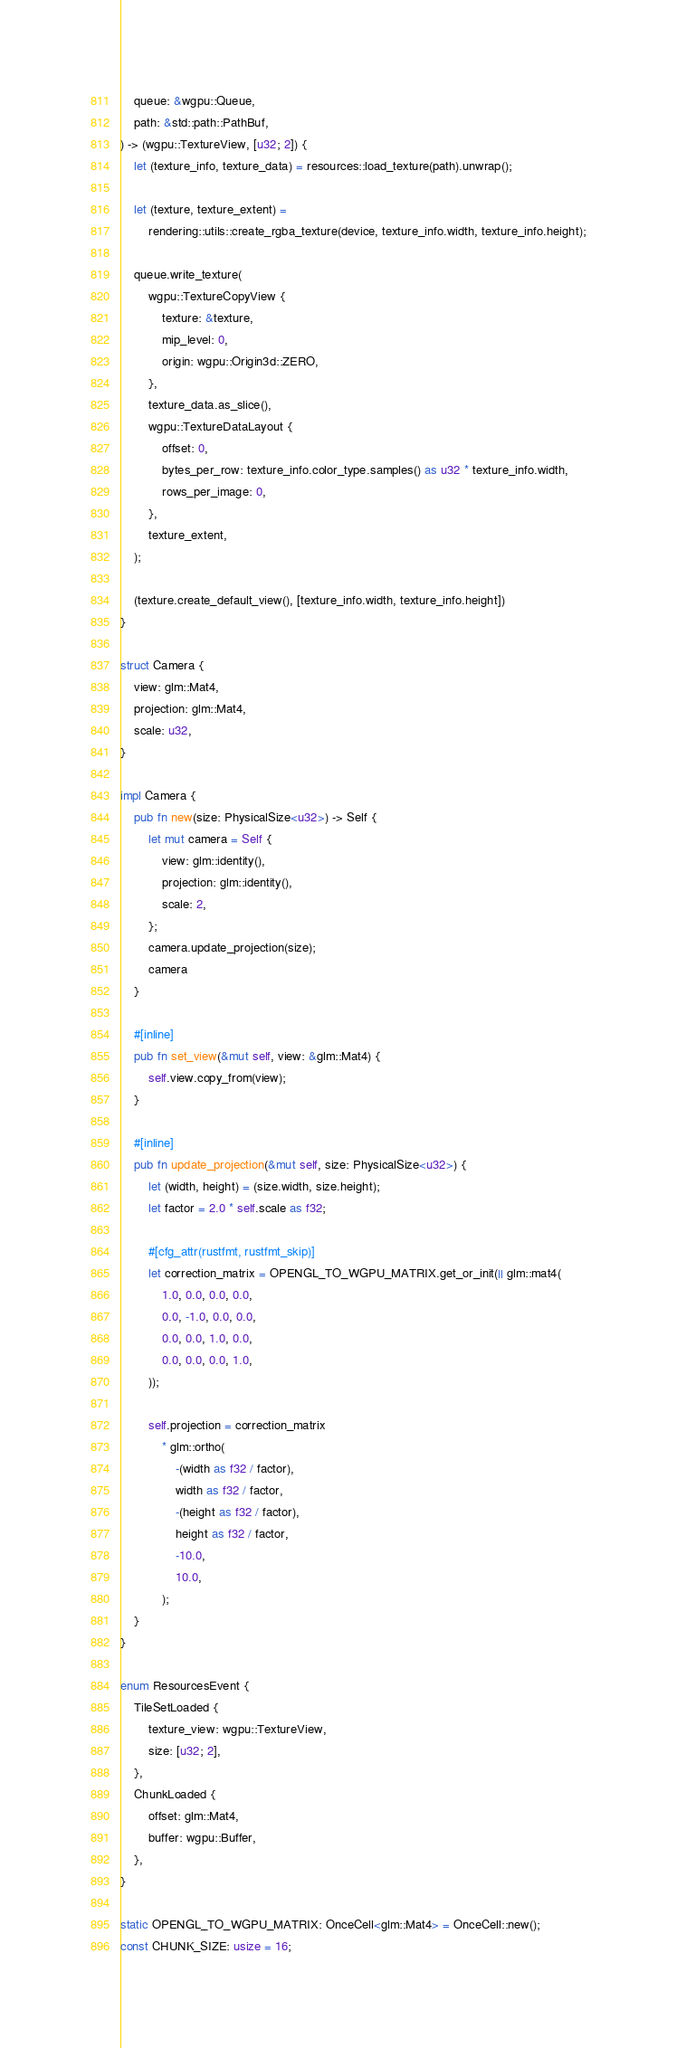Convert code to text. <code><loc_0><loc_0><loc_500><loc_500><_Rust_>    queue: &wgpu::Queue,
    path: &std::path::PathBuf,
) -> (wgpu::TextureView, [u32; 2]) {
    let (texture_info, texture_data) = resources::load_texture(path).unwrap();

    let (texture, texture_extent) =
        rendering::utils::create_rgba_texture(device, texture_info.width, texture_info.height);

    queue.write_texture(
        wgpu::TextureCopyView {
            texture: &texture,
            mip_level: 0,
            origin: wgpu::Origin3d::ZERO,
        },
        texture_data.as_slice(),
        wgpu::TextureDataLayout {
            offset: 0,
            bytes_per_row: texture_info.color_type.samples() as u32 * texture_info.width,
            rows_per_image: 0,
        },
        texture_extent,
    );

    (texture.create_default_view(), [texture_info.width, texture_info.height])
}

struct Camera {
    view: glm::Mat4,
    projection: glm::Mat4,
    scale: u32,
}

impl Camera {
    pub fn new(size: PhysicalSize<u32>) -> Self {
        let mut camera = Self {
            view: glm::identity(),
            projection: glm::identity(),
            scale: 2,
        };
        camera.update_projection(size);
        camera
    }

    #[inline]
    pub fn set_view(&mut self, view: &glm::Mat4) {
        self.view.copy_from(view);
    }

    #[inline]
    pub fn update_projection(&mut self, size: PhysicalSize<u32>) {
        let (width, height) = (size.width, size.height);
        let factor = 2.0 * self.scale as f32;

        #[cfg_attr(rustfmt, rustfmt_skip)]
        let correction_matrix = OPENGL_TO_WGPU_MATRIX.get_or_init(|| glm::mat4(
            1.0, 0.0, 0.0, 0.0,
            0.0, -1.0, 0.0, 0.0,
            0.0, 0.0, 1.0, 0.0,
            0.0, 0.0, 0.0, 1.0,
        ));

        self.projection = correction_matrix
            * glm::ortho(
                -(width as f32 / factor),
                width as f32 / factor,
                -(height as f32 / factor),
                height as f32 / factor,
                -10.0,
                10.0,
            );
    }
}

enum ResourcesEvent {
    TileSetLoaded {
        texture_view: wgpu::TextureView,
        size: [u32; 2],
    },
    ChunkLoaded {
        offset: glm::Mat4,
        buffer: wgpu::Buffer,
    },
}

static OPENGL_TO_WGPU_MATRIX: OnceCell<glm::Mat4> = OnceCell::new();
const CHUNK_SIZE: usize = 16;
</code> 